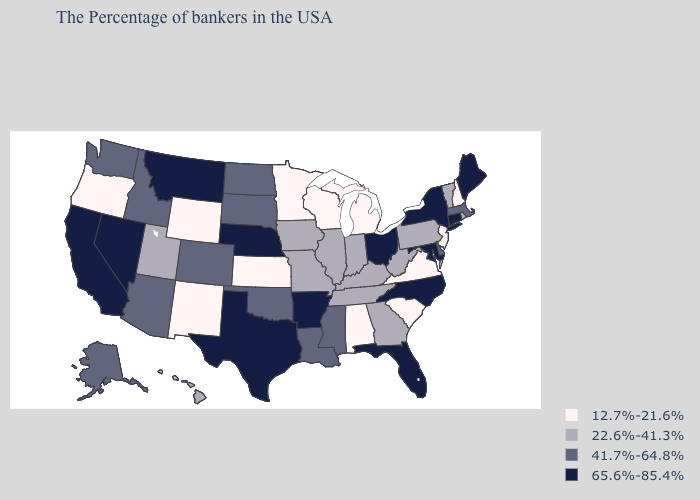Name the states that have a value in the range 22.6%-41.3%?
Short answer required. Rhode Island, Vermont, Pennsylvania, West Virginia, Georgia, Kentucky, Indiana, Tennessee, Illinois, Missouri, Iowa, Utah, Hawaii. What is the highest value in states that border Texas?
Short answer required. 65.6%-85.4%. Which states have the lowest value in the USA?
Quick response, please. New Hampshire, New Jersey, Virginia, South Carolina, Michigan, Alabama, Wisconsin, Minnesota, Kansas, Wyoming, New Mexico, Oregon. Among the states that border Oklahoma , does New Mexico have the lowest value?
Write a very short answer. Yes. Name the states that have a value in the range 22.6%-41.3%?
Keep it brief. Rhode Island, Vermont, Pennsylvania, West Virginia, Georgia, Kentucky, Indiana, Tennessee, Illinois, Missouri, Iowa, Utah, Hawaii. Which states have the lowest value in the South?
Give a very brief answer. Virginia, South Carolina, Alabama. Which states have the lowest value in the MidWest?
Write a very short answer. Michigan, Wisconsin, Minnesota, Kansas. Among the states that border Wyoming , does Idaho have the lowest value?
Concise answer only. No. What is the value of Kansas?
Short answer required. 12.7%-21.6%. What is the value of Montana?
Write a very short answer. 65.6%-85.4%. What is the value of Rhode Island?
Give a very brief answer. 22.6%-41.3%. What is the value of Arizona?
Be succinct. 41.7%-64.8%. What is the value of Connecticut?
Be succinct. 65.6%-85.4%. What is the highest value in the Northeast ?
Short answer required. 65.6%-85.4%. Name the states that have a value in the range 65.6%-85.4%?
Concise answer only. Maine, Connecticut, New York, Maryland, North Carolina, Ohio, Florida, Arkansas, Nebraska, Texas, Montana, Nevada, California. 